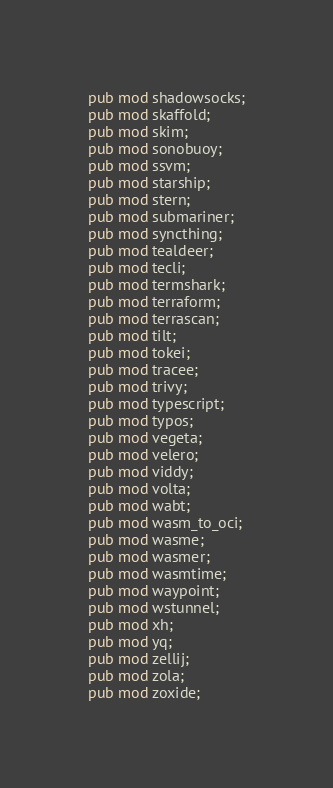<code> <loc_0><loc_0><loc_500><loc_500><_Rust_>pub mod shadowsocks;
pub mod skaffold;
pub mod skim;
pub mod sonobuoy;
pub mod ssvm;
pub mod starship;
pub mod stern;
pub mod submariner;
pub mod syncthing;
pub mod tealdeer;
pub mod tecli;
pub mod termshark;
pub mod terraform;
pub mod terrascan;
pub mod tilt;
pub mod tokei;
pub mod tracee;
pub mod trivy;
pub mod typescript;
pub mod typos;
pub mod vegeta;
pub mod velero;
pub mod viddy;
pub mod volta;
pub mod wabt;
pub mod wasm_to_oci;
pub mod wasme;
pub mod wasmer;
pub mod wasmtime;
pub mod waypoint;
pub mod wstunnel;
pub mod xh;
pub mod yq;
pub mod zellij;
pub mod zola;
pub mod zoxide;
</code> 